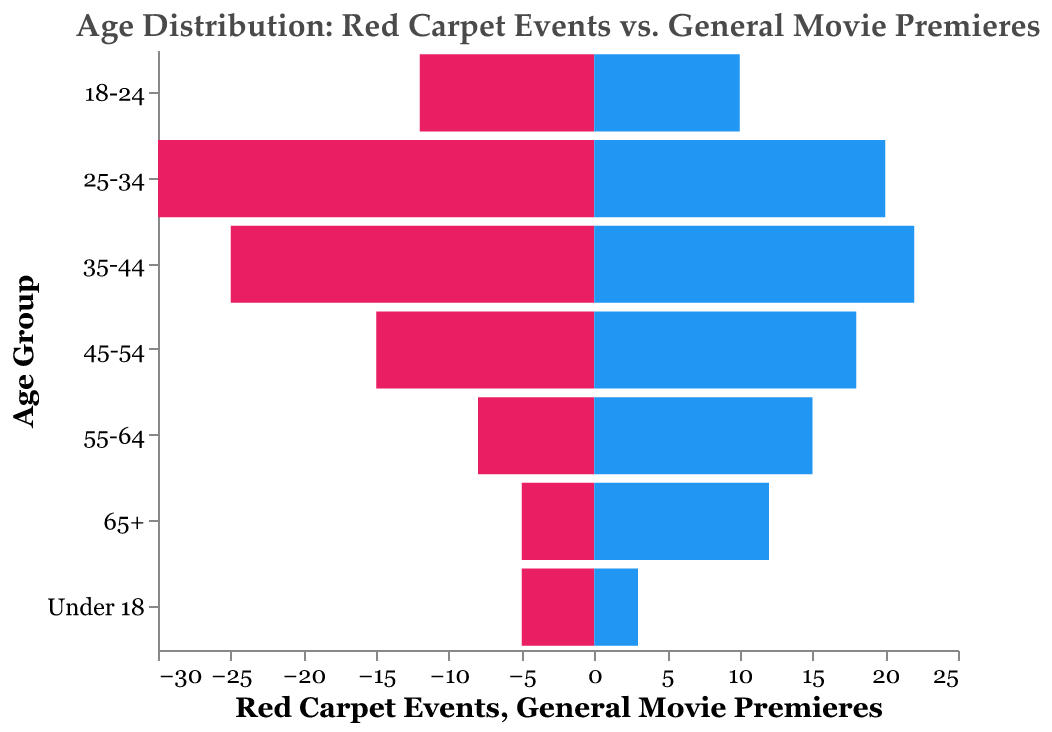What's the title of the figure? The title of the figure can be understood at first glance from the top of the chart.
Answer: Age Distribution: Red Carpet Events vs. General Movie Premieres What age group has the highest attendance at red carpet events? Look for the bar with the highest length on the Red Carpet Events side (colored in pink).
Answer: 25-34 How many people from the 55-64 age group attend general movie premieres? Check the value associated with the 55-64 age group on the General Movie Premieres side (colored in blue).
Answer: 15 What is the difference in attendance for people aged 18-24 between red carpet events and general movie premieres? Calculate the absolute difference between the red carpet (12) and general movie premiere (10) values for the 18-24 age group:
Answer: 2 Which event type has higher attendance from the 45-54 age group? Compare the lengths of the bars for the 45-54 age group on both event types.
Answer: General Movie Premieres How many more people aged 25-34 attend red carpet events compared to general movie premieres? Subtract the number for general movie premieres (20) from the number for red carpet events (30) for the 25-34 age group. 30 - 20 = 10
Answer: 10 What is the combined total attendance for the 35-44 age group at both events? Add the number of attendees for the 35-44 age group at red carpet events (25) and general movie premieres (22). 25 + 22 = 47
Answer: 47 How does the attendance for people aged under 18 differ between red carpet events and general movie premieres? Compare the lengths of the bars for each event type in the under 18 category. The difference is 5 - 3 = 2.
Answer: 2 